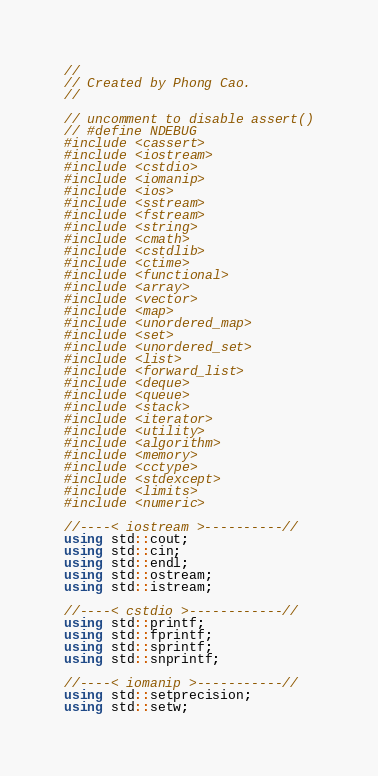<code> <loc_0><loc_0><loc_500><loc_500><_C++_>//
// Created by Phong Cao.
//

// uncomment to disable assert()
// #define NDEBUG
#include <cassert>
#include <iostream>
#include <cstdio>
#include <iomanip>
#include <ios>
#include <sstream>
#include <fstream>
#include <string>
#include <cmath>
#include <cstdlib>
#include <ctime>
#include <functional>
#include <array>
#include <vector>
#include <map>
#include <unordered_map>
#include <set>
#include <unordered_set>
#include <list>
#include <forward_list>
#include <deque>
#include <queue>
#include <stack>
#include <iterator>
#include <utility>
#include <algorithm>
#include <memory>
#include <cctype>
#include <stdexcept>
#include <limits>
#include <numeric>

//----< iostream >----------//
using std::cout;
using std::cin;
using std::endl;
using std::ostream;
using std::istream;

//----< cstdio >------------//
using std::printf;
using std::fprintf;
using std::sprintf;
using std::snprintf;

//----< iomanip >-----------//
using std::setprecision;
using std::setw;
</code> 